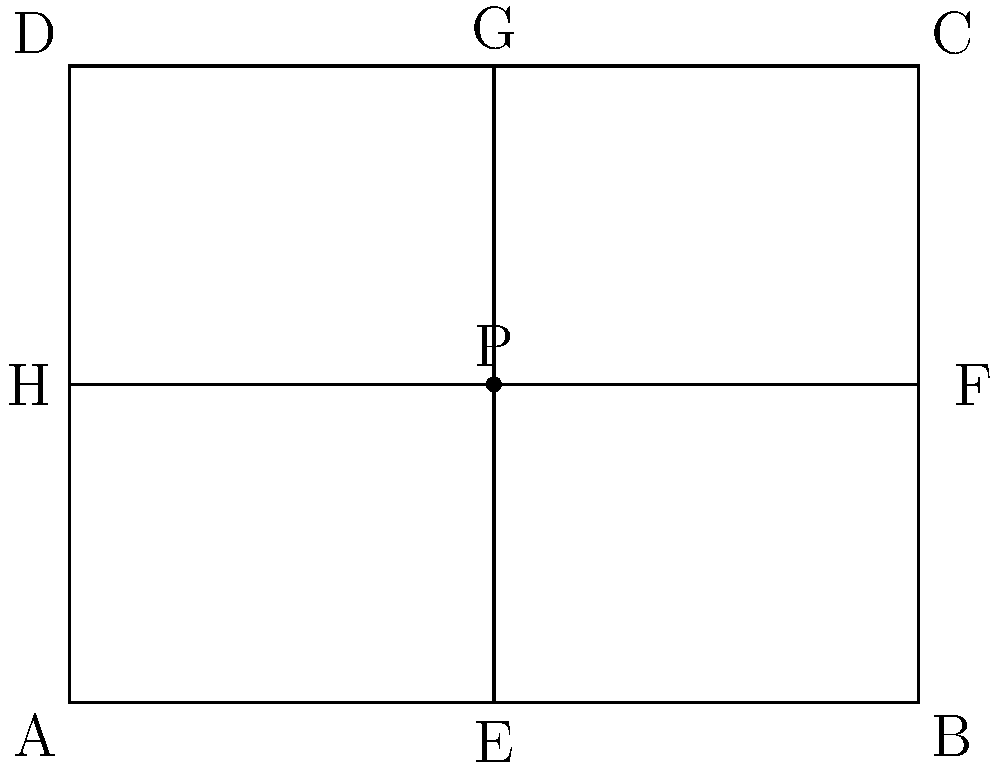In the diagram representing human body proportions, rectangle ABCD models the frontal view of a human torso. Point P is the intersection of the midlines EG and HF. If the ratio of AP:PG is 1:2, and the area of rectangle ABCD is 12 square units, what is the length of diagonal AC? How might this ratio and symmetry relate to evolutionary adaptations in human body structure? To solve this problem, we'll follow these steps:

1) First, let's identify the given information:
   - The ratio of AP:PG is 1:2
   - The area of rectangle ABCD is 12 square units

2) Since P is the intersection of the midlines, we know that:
   - AE = EB = DH = HC
   - AG = GC = EH = FD

3) The ratio AP:PG = 1:2 implies that AP = 1x and PG = 2x, where x is some length unit.
   Therefore, AG = AP + PG = 1x + 2x = 3x

4) Now, let's find the dimensions of the rectangle:
   - Area of rectangle = length × width = 12 sq units
   - Let the width (AB) be w and height (AD) be h
   - w × h = 12

5) We know that AG = 3x = h (the height of the rectangle)
   So, h = 3x

6) Substituting this into the area equation:
   w × 3x = 12
   w = 12 / (3x) = 4/x

7) Now we can find x:
   Area = w × h = (4/x) × 3x = 12
   12x = 12
   x = 1

8) So, the dimensions of the rectangle are:
   width (w) = 4 units
   height (h) = 3 units

9) To find the length of diagonal AC, we can use the Pythagorean theorem:
   $AC^2 = AB^2 + BC^2 = 4^2 + 3^2 = 16 + 9 = 25$
   $AC = \sqrt{25} = 5$ units

10) Evolutionary perspective:
    The 1:2 ratio in vertical body proportions (AP:PG) could relate to the golden ratio (approximately 1:1.618), which is often found in nature and considered aesthetically pleasing. This ratio might have evolved as it provides a balance between upper and lower body strength, facilitating bipedal locomotion and tool use, key factors in human evolution.

    The symmetry observed in the horizontal plane (left-right symmetry) is common in bilaterally symmetric animals and has been conserved through evolution, possibly due to its advantages in locomotion and sensory processing.

    The overall proportions of the human torso, represented by the 4:3 ratio of width to height, might reflect adaptations for upright posture, efficient breathing, and protection of vital organs.
Answer: 5 units; ratio and symmetry optimize bipedal locomotion, tool use, and vital organ protection. 